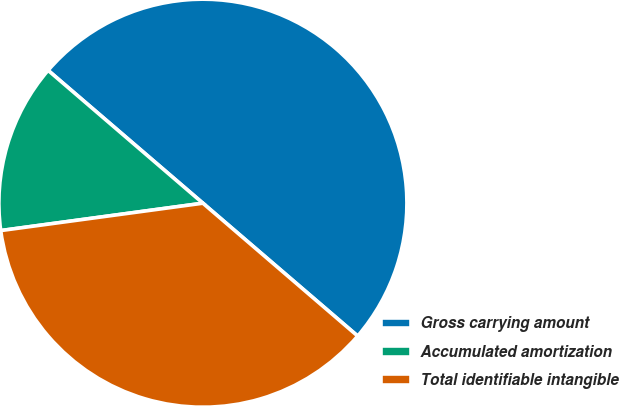Convert chart. <chart><loc_0><loc_0><loc_500><loc_500><pie_chart><fcel>Gross carrying amount<fcel>Accumulated amortization<fcel>Total identifiable intangible<nl><fcel>50.0%<fcel>13.43%<fcel>36.57%<nl></chart> 